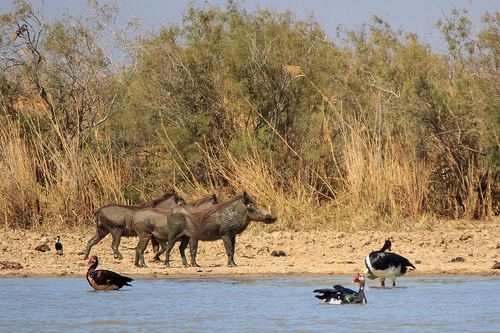<image>
Can you confirm if the water is to the right of the boar? Yes. From this viewpoint, the water is positioned to the right side relative to the boar. Is the animal in the water? No. The animal is not contained within the water. These objects have a different spatial relationship. 